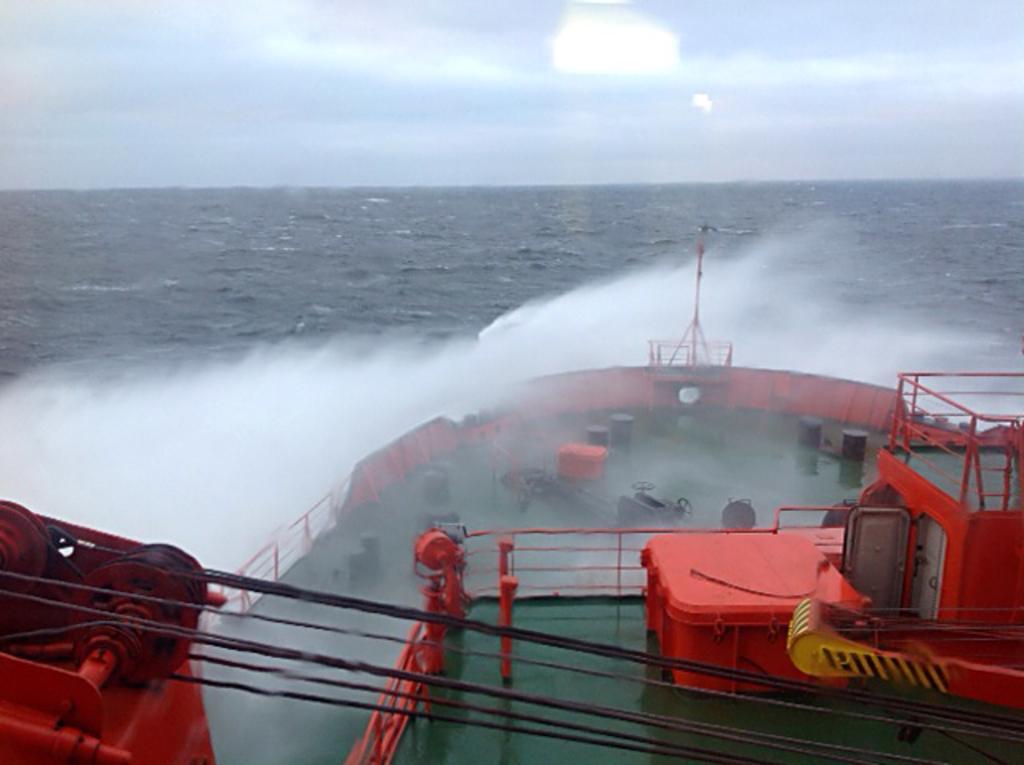Please provide a concise description of this image. In this image I can see a ship in the water. At the top I can see clouds in the sky. 